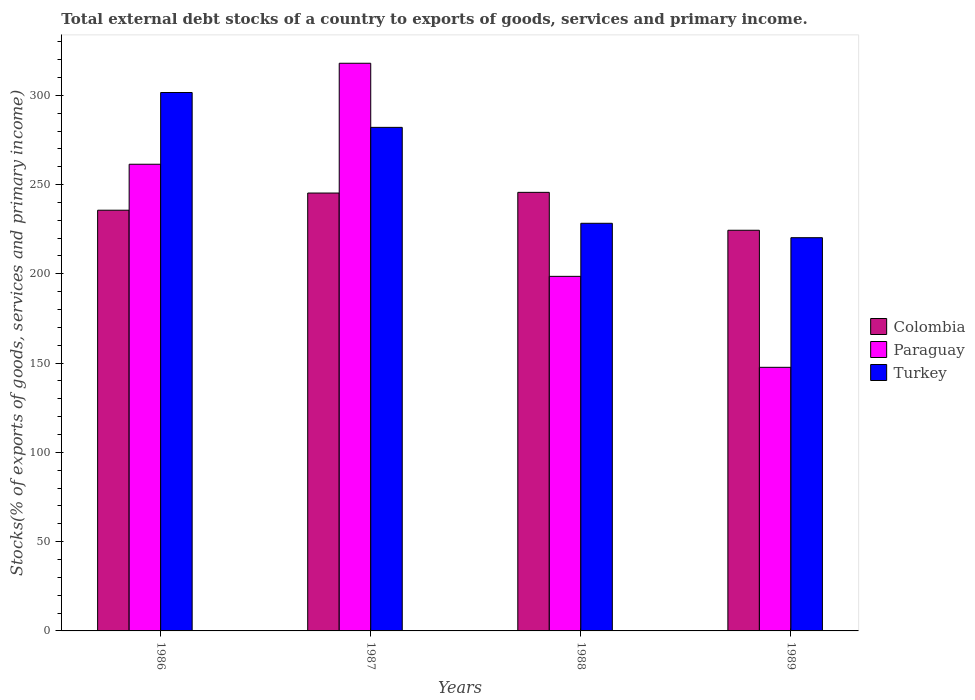What is the label of the 2nd group of bars from the left?
Your response must be concise. 1987. In how many cases, is the number of bars for a given year not equal to the number of legend labels?
Offer a very short reply. 0. What is the total debt stocks in Colombia in 1988?
Your response must be concise. 245.64. Across all years, what is the maximum total debt stocks in Colombia?
Provide a succinct answer. 245.64. Across all years, what is the minimum total debt stocks in Colombia?
Provide a short and direct response. 224.41. In which year was the total debt stocks in Colombia minimum?
Give a very brief answer. 1989. What is the total total debt stocks in Paraguay in the graph?
Provide a short and direct response. 925.55. What is the difference between the total debt stocks in Colombia in 1986 and that in 1989?
Your response must be concise. 11.22. What is the difference between the total debt stocks in Paraguay in 1986 and the total debt stocks in Turkey in 1988?
Provide a short and direct response. 33.07. What is the average total debt stocks in Paraguay per year?
Provide a succinct answer. 231.39. In the year 1986, what is the difference between the total debt stocks in Colombia and total debt stocks in Turkey?
Provide a succinct answer. -65.93. What is the ratio of the total debt stocks in Colombia in 1987 to that in 1989?
Your answer should be very brief. 1.09. What is the difference between the highest and the second highest total debt stocks in Paraguay?
Keep it short and to the point. 56.56. What is the difference between the highest and the lowest total debt stocks in Colombia?
Give a very brief answer. 21.23. What does the 3rd bar from the left in 1989 represents?
Ensure brevity in your answer.  Turkey. Is it the case that in every year, the sum of the total debt stocks in Colombia and total debt stocks in Paraguay is greater than the total debt stocks in Turkey?
Your answer should be compact. Yes. How many bars are there?
Your answer should be compact. 12. How many years are there in the graph?
Make the answer very short. 4. What is the difference between two consecutive major ticks on the Y-axis?
Your answer should be very brief. 50. Where does the legend appear in the graph?
Offer a terse response. Center right. How many legend labels are there?
Your answer should be very brief. 3. What is the title of the graph?
Give a very brief answer. Total external debt stocks of a country to exports of goods, services and primary income. What is the label or title of the Y-axis?
Make the answer very short. Stocks(% of exports of goods, services and primary income). What is the Stocks(% of exports of goods, services and primary income) of Colombia in 1986?
Your response must be concise. 235.63. What is the Stocks(% of exports of goods, services and primary income) in Paraguay in 1986?
Give a very brief answer. 261.38. What is the Stocks(% of exports of goods, services and primary income) in Turkey in 1986?
Your answer should be very brief. 301.56. What is the Stocks(% of exports of goods, services and primary income) of Colombia in 1987?
Provide a succinct answer. 245.25. What is the Stocks(% of exports of goods, services and primary income) of Paraguay in 1987?
Offer a terse response. 317.94. What is the Stocks(% of exports of goods, services and primary income) of Turkey in 1987?
Provide a succinct answer. 282.04. What is the Stocks(% of exports of goods, services and primary income) of Colombia in 1988?
Keep it short and to the point. 245.64. What is the Stocks(% of exports of goods, services and primary income) of Paraguay in 1988?
Your answer should be very brief. 198.59. What is the Stocks(% of exports of goods, services and primary income) in Turkey in 1988?
Offer a very short reply. 228.31. What is the Stocks(% of exports of goods, services and primary income) of Colombia in 1989?
Provide a short and direct response. 224.41. What is the Stocks(% of exports of goods, services and primary income) of Paraguay in 1989?
Offer a terse response. 147.64. What is the Stocks(% of exports of goods, services and primary income) of Turkey in 1989?
Your response must be concise. 220.24. Across all years, what is the maximum Stocks(% of exports of goods, services and primary income) in Colombia?
Your response must be concise. 245.64. Across all years, what is the maximum Stocks(% of exports of goods, services and primary income) in Paraguay?
Your response must be concise. 317.94. Across all years, what is the maximum Stocks(% of exports of goods, services and primary income) of Turkey?
Your answer should be compact. 301.56. Across all years, what is the minimum Stocks(% of exports of goods, services and primary income) of Colombia?
Your response must be concise. 224.41. Across all years, what is the minimum Stocks(% of exports of goods, services and primary income) of Paraguay?
Your answer should be compact. 147.64. Across all years, what is the minimum Stocks(% of exports of goods, services and primary income) in Turkey?
Provide a succinct answer. 220.24. What is the total Stocks(% of exports of goods, services and primary income) of Colombia in the graph?
Your answer should be compact. 950.93. What is the total Stocks(% of exports of goods, services and primary income) in Paraguay in the graph?
Your answer should be very brief. 925.55. What is the total Stocks(% of exports of goods, services and primary income) of Turkey in the graph?
Offer a very short reply. 1032.15. What is the difference between the Stocks(% of exports of goods, services and primary income) in Colombia in 1986 and that in 1987?
Offer a very short reply. -9.62. What is the difference between the Stocks(% of exports of goods, services and primary income) in Paraguay in 1986 and that in 1987?
Make the answer very short. -56.56. What is the difference between the Stocks(% of exports of goods, services and primary income) of Turkey in 1986 and that in 1987?
Provide a short and direct response. 19.52. What is the difference between the Stocks(% of exports of goods, services and primary income) of Colombia in 1986 and that in 1988?
Keep it short and to the point. -10. What is the difference between the Stocks(% of exports of goods, services and primary income) in Paraguay in 1986 and that in 1988?
Offer a terse response. 62.79. What is the difference between the Stocks(% of exports of goods, services and primary income) of Turkey in 1986 and that in 1988?
Give a very brief answer. 73.25. What is the difference between the Stocks(% of exports of goods, services and primary income) of Colombia in 1986 and that in 1989?
Your answer should be very brief. 11.22. What is the difference between the Stocks(% of exports of goods, services and primary income) in Paraguay in 1986 and that in 1989?
Offer a terse response. 113.74. What is the difference between the Stocks(% of exports of goods, services and primary income) of Turkey in 1986 and that in 1989?
Provide a succinct answer. 81.32. What is the difference between the Stocks(% of exports of goods, services and primary income) in Colombia in 1987 and that in 1988?
Make the answer very short. -0.38. What is the difference between the Stocks(% of exports of goods, services and primary income) of Paraguay in 1987 and that in 1988?
Provide a succinct answer. 119.36. What is the difference between the Stocks(% of exports of goods, services and primary income) in Turkey in 1987 and that in 1988?
Your response must be concise. 53.73. What is the difference between the Stocks(% of exports of goods, services and primary income) in Colombia in 1987 and that in 1989?
Your answer should be compact. 20.84. What is the difference between the Stocks(% of exports of goods, services and primary income) in Paraguay in 1987 and that in 1989?
Offer a terse response. 170.3. What is the difference between the Stocks(% of exports of goods, services and primary income) of Turkey in 1987 and that in 1989?
Give a very brief answer. 61.8. What is the difference between the Stocks(% of exports of goods, services and primary income) of Colombia in 1988 and that in 1989?
Your answer should be compact. 21.23. What is the difference between the Stocks(% of exports of goods, services and primary income) in Paraguay in 1988 and that in 1989?
Your answer should be very brief. 50.95. What is the difference between the Stocks(% of exports of goods, services and primary income) in Turkey in 1988 and that in 1989?
Your answer should be very brief. 8.07. What is the difference between the Stocks(% of exports of goods, services and primary income) in Colombia in 1986 and the Stocks(% of exports of goods, services and primary income) in Paraguay in 1987?
Make the answer very short. -82.31. What is the difference between the Stocks(% of exports of goods, services and primary income) in Colombia in 1986 and the Stocks(% of exports of goods, services and primary income) in Turkey in 1987?
Give a very brief answer. -46.41. What is the difference between the Stocks(% of exports of goods, services and primary income) of Paraguay in 1986 and the Stocks(% of exports of goods, services and primary income) of Turkey in 1987?
Provide a short and direct response. -20.66. What is the difference between the Stocks(% of exports of goods, services and primary income) in Colombia in 1986 and the Stocks(% of exports of goods, services and primary income) in Paraguay in 1988?
Keep it short and to the point. 37.04. What is the difference between the Stocks(% of exports of goods, services and primary income) in Colombia in 1986 and the Stocks(% of exports of goods, services and primary income) in Turkey in 1988?
Provide a short and direct response. 7.32. What is the difference between the Stocks(% of exports of goods, services and primary income) in Paraguay in 1986 and the Stocks(% of exports of goods, services and primary income) in Turkey in 1988?
Provide a short and direct response. 33.07. What is the difference between the Stocks(% of exports of goods, services and primary income) of Colombia in 1986 and the Stocks(% of exports of goods, services and primary income) of Paraguay in 1989?
Offer a very short reply. 87.99. What is the difference between the Stocks(% of exports of goods, services and primary income) in Colombia in 1986 and the Stocks(% of exports of goods, services and primary income) in Turkey in 1989?
Give a very brief answer. 15.39. What is the difference between the Stocks(% of exports of goods, services and primary income) of Paraguay in 1986 and the Stocks(% of exports of goods, services and primary income) of Turkey in 1989?
Make the answer very short. 41.14. What is the difference between the Stocks(% of exports of goods, services and primary income) in Colombia in 1987 and the Stocks(% of exports of goods, services and primary income) in Paraguay in 1988?
Offer a very short reply. 46.66. What is the difference between the Stocks(% of exports of goods, services and primary income) in Colombia in 1987 and the Stocks(% of exports of goods, services and primary income) in Turkey in 1988?
Give a very brief answer. 16.94. What is the difference between the Stocks(% of exports of goods, services and primary income) in Paraguay in 1987 and the Stocks(% of exports of goods, services and primary income) in Turkey in 1988?
Give a very brief answer. 89.64. What is the difference between the Stocks(% of exports of goods, services and primary income) in Colombia in 1987 and the Stocks(% of exports of goods, services and primary income) in Paraguay in 1989?
Give a very brief answer. 97.61. What is the difference between the Stocks(% of exports of goods, services and primary income) in Colombia in 1987 and the Stocks(% of exports of goods, services and primary income) in Turkey in 1989?
Your answer should be very brief. 25.01. What is the difference between the Stocks(% of exports of goods, services and primary income) of Paraguay in 1987 and the Stocks(% of exports of goods, services and primary income) of Turkey in 1989?
Offer a very short reply. 97.7. What is the difference between the Stocks(% of exports of goods, services and primary income) in Colombia in 1988 and the Stocks(% of exports of goods, services and primary income) in Paraguay in 1989?
Provide a succinct answer. 98. What is the difference between the Stocks(% of exports of goods, services and primary income) of Colombia in 1988 and the Stocks(% of exports of goods, services and primary income) of Turkey in 1989?
Ensure brevity in your answer.  25.4. What is the difference between the Stocks(% of exports of goods, services and primary income) in Paraguay in 1988 and the Stocks(% of exports of goods, services and primary income) in Turkey in 1989?
Provide a short and direct response. -21.65. What is the average Stocks(% of exports of goods, services and primary income) in Colombia per year?
Your response must be concise. 237.73. What is the average Stocks(% of exports of goods, services and primary income) in Paraguay per year?
Make the answer very short. 231.39. What is the average Stocks(% of exports of goods, services and primary income) in Turkey per year?
Provide a short and direct response. 258.04. In the year 1986, what is the difference between the Stocks(% of exports of goods, services and primary income) of Colombia and Stocks(% of exports of goods, services and primary income) of Paraguay?
Offer a very short reply. -25.75. In the year 1986, what is the difference between the Stocks(% of exports of goods, services and primary income) in Colombia and Stocks(% of exports of goods, services and primary income) in Turkey?
Offer a very short reply. -65.93. In the year 1986, what is the difference between the Stocks(% of exports of goods, services and primary income) in Paraguay and Stocks(% of exports of goods, services and primary income) in Turkey?
Keep it short and to the point. -40.18. In the year 1987, what is the difference between the Stocks(% of exports of goods, services and primary income) in Colombia and Stocks(% of exports of goods, services and primary income) in Paraguay?
Provide a short and direct response. -72.69. In the year 1987, what is the difference between the Stocks(% of exports of goods, services and primary income) of Colombia and Stocks(% of exports of goods, services and primary income) of Turkey?
Offer a terse response. -36.79. In the year 1987, what is the difference between the Stocks(% of exports of goods, services and primary income) in Paraguay and Stocks(% of exports of goods, services and primary income) in Turkey?
Your response must be concise. 35.91. In the year 1988, what is the difference between the Stocks(% of exports of goods, services and primary income) in Colombia and Stocks(% of exports of goods, services and primary income) in Paraguay?
Your response must be concise. 47.05. In the year 1988, what is the difference between the Stocks(% of exports of goods, services and primary income) in Colombia and Stocks(% of exports of goods, services and primary income) in Turkey?
Provide a short and direct response. 17.33. In the year 1988, what is the difference between the Stocks(% of exports of goods, services and primary income) of Paraguay and Stocks(% of exports of goods, services and primary income) of Turkey?
Your response must be concise. -29.72. In the year 1989, what is the difference between the Stocks(% of exports of goods, services and primary income) of Colombia and Stocks(% of exports of goods, services and primary income) of Paraguay?
Keep it short and to the point. 76.77. In the year 1989, what is the difference between the Stocks(% of exports of goods, services and primary income) of Colombia and Stocks(% of exports of goods, services and primary income) of Turkey?
Give a very brief answer. 4.17. In the year 1989, what is the difference between the Stocks(% of exports of goods, services and primary income) in Paraguay and Stocks(% of exports of goods, services and primary income) in Turkey?
Provide a succinct answer. -72.6. What is the ratio of the Stocks(% of exports of goods, services and primary income) of Colombia in 1986 to that in 1987?
Your response must be concise. 0.96. What is the ratio of the Stocks(% of exports of goods, services and primary income) of Paraguay in 1986 to that in 1987?
Your answer should be compact. 0.82. What is the ratio of the Stocks(% of exports of goods, services and primary income) in Turkey in 1986 to that in 1987?
Offer a terse response. 1.07. What is the ratio of the Stocks(% of exports of goods, services and primary income) of Colombia in 1986 to that in 1988?
Make the answer very short. 0.96. What is the ratio of the Stocks(% of exports of goods, services and primary income) of Paraguay in 1986 to that in 1988?
Give a very brief answer. 1.32. What is the ratio of the Stocks(% of exports of goods, services and primary income) of Turkey in 1986 to that in 1988?
Your answer should be very brief. 1.32. What is the ratio of the Stocks(% of exports of goods, services and primary income) in Colombia in 1986 to that in 1989?
Offer a terse response. 1.05. What is the ratio of the Stocks(% of exports of goods, services and primary income) of Paraguay in 1986 to that in 1989?
Ensure brevity in your answer.  1.77. What is the ratio of the Stocks(% of exports of goods, services and primary income) of Turkey in 1986 to that in 1989?
Offer a very short reply. 1.37. What is the ratio of the Stocks(% of exports of goods, services and primary income) of Colombia in 1987 to that in 1988?
Make the answer very short. 1. What is the ratio of the Stocks(% of exports of goods, services and primary income) of Paraguay in 1987 to that in 1988?
Your answer should be compact. 1.6. What is the ratio of the Stocks(% of exports of goods, services and primary income) in Turkey in 1987 to that in 1988?
Offer a terse response. 1.24. What is the ratio of the Stocks(% of exports of goods, services and primary income) of Colombia in 1987 to that in 1989?
Offer a very short reply. 1.09. What is the ratio of the Stocks(% of exports of goods, services and primary income) in Paraguay in 1987 to that in 1989?
Provide a succinct answer. 2.15. What is the ratio of the Stocks(% of exports of goods, services and primary income) in Turkey in 1987 to that in 1989?
Provide a succinct answer. 1.28. What is the ratio of the Stocks(% of exports of goods, services and primary income) of Colombia in 1988 to that in 1989?
Offer a terse response. 1.09. What is the ratio of the Stocks(% of exports of goods, services and primary income) in Paraguay in 1988 to that in 1989?
Give a very brief answer. 1.35. What is the ratio of the Stocks(% of exports of goods, services and primary income) of Turkey in 1988 to that in 1989?
Provide a short and direct response. 1.04. What is the difference between the highest and the second highest Stocks(% of exports of goods, services and primary income) of Colombia?
Make the answer very short. 0.38. What is the difference between the highest and the second highest Stocks(% of exports of goods, services and primary income) of Paraguay?
Offer a very short reply. 56.56. What is the difference between the highest and the second highest Stocks(% of exports of goods, services and primary income) in Turkey?
Provide a short and direct response. 19.52. What is the difference between the highest and the lowest Stocks(% of exports of goods, services and primary income) in Colombia?
Ensure brevity in your answer.  21.23. What is the difference between the highest and the lowest Stocks(% of exports of goods, services and primary income) in Paraguay?
Make the answer very short. 170.3. What is the difference between the highest and the lowest Stocks(% of exports of goods, services and primary income) in Turkey?
Provide a succinct answer. 81.32. 